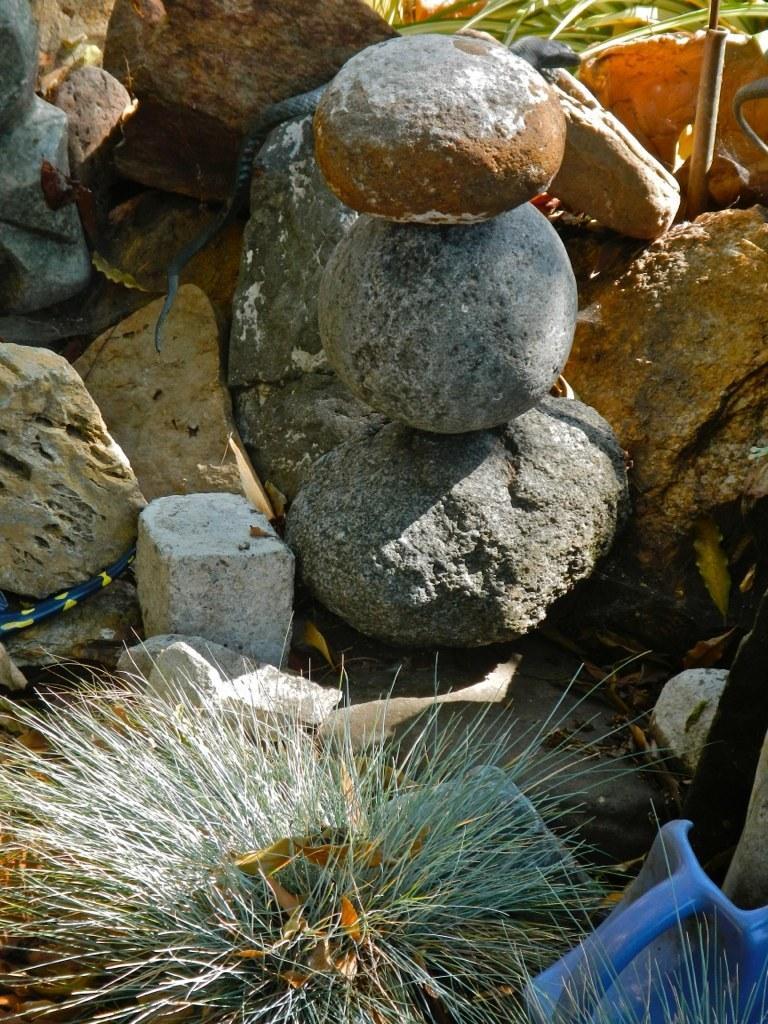Please provide a concise description of this image. In this picture I can observe some stones on the ground. On the bottom of the picture I can observe a plant. 